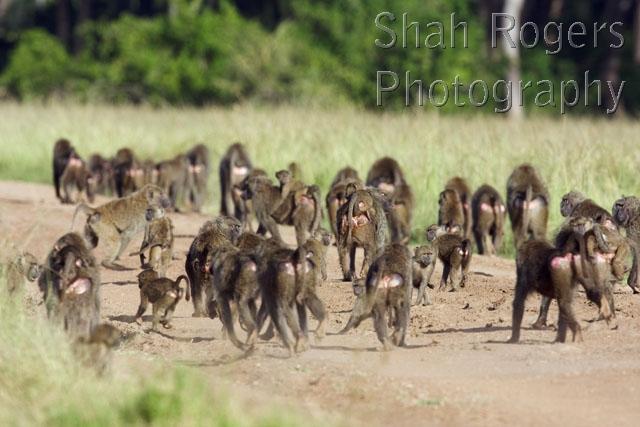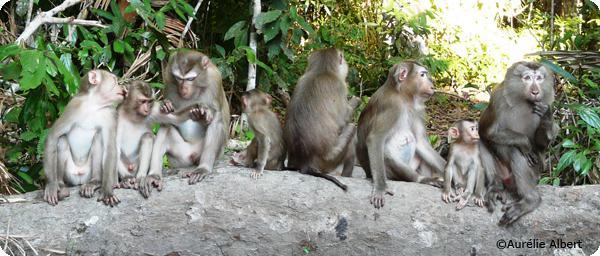The first image is the image on the left, the second image is the image on the right. For the images shown, is this caption "The image on the left shows a single chimp in the leaves of a tree." true? Answer yes or no. No. The first image is the image on the left, the second image is the image on the right. Examine the images to the left and right. Is the description "Left image shows one baboon, posed amid leafy foliage." accurate? Answer yes or no. No. 